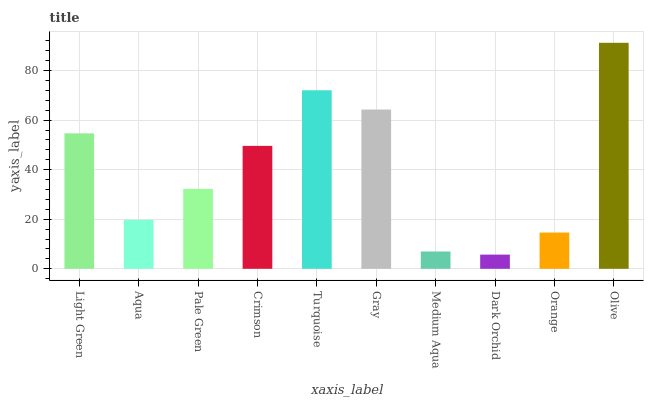Is Dark Orchid the minimum?
Answer yes or no. Yes. Is Olive the maximum?
Answer yes or no. Yes. Is Aqua the minimum?
Answer yes or no. No. Is Aqua the maximum?
Answer yes or no. No. Is Light Green greater than Aqua?
Answer yes or no. Yes. Is Aqua less than Light Green?
Answer yes or no. Yes. Is Aqua greater than Light Green?
Answer yes or no. No. Is Light Green less than Aqua?
Answer yes or no. No. Is Crimson the high median?
Answer yes or no. Yes. Is Pale Green the low median?
Answer yes or no. Yes. Is Medium Aqua the high median?
Answer yes or no. No. Is Dark Orchid the low median?
Answer yes or no. No. 